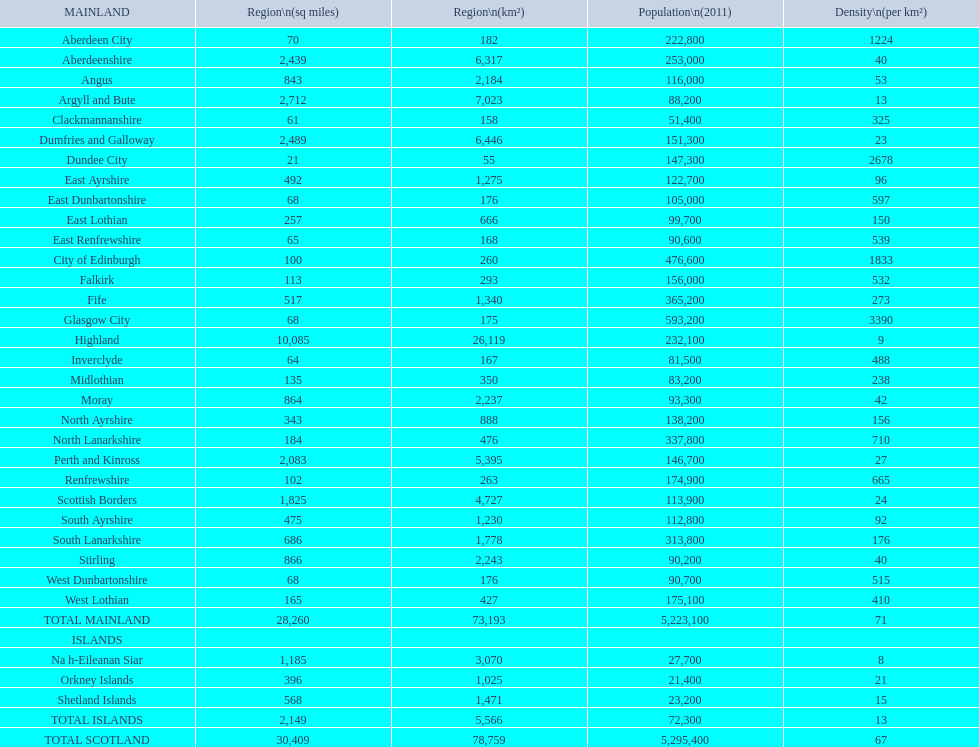What is the total area of east lothian, angus, and dundee city? 1121. 